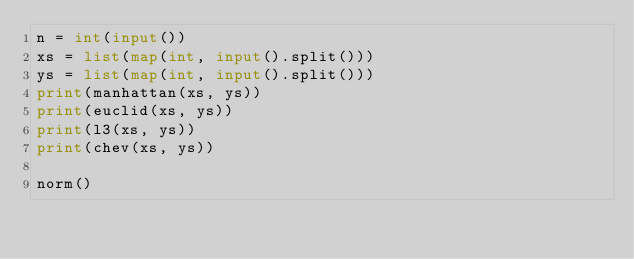Convert code to text. <code><loc_0><loc_0><loc_500><loc_500><_Python_>n = int(input())
xs = list(map(int, input().split()))
ys = list(map(int, input().split()))
print(manhattan(xs, ys))
print(euclid(xs, ys))
print(l3(xs, ys))
print(chev(xs, ys))

norm()</code> 